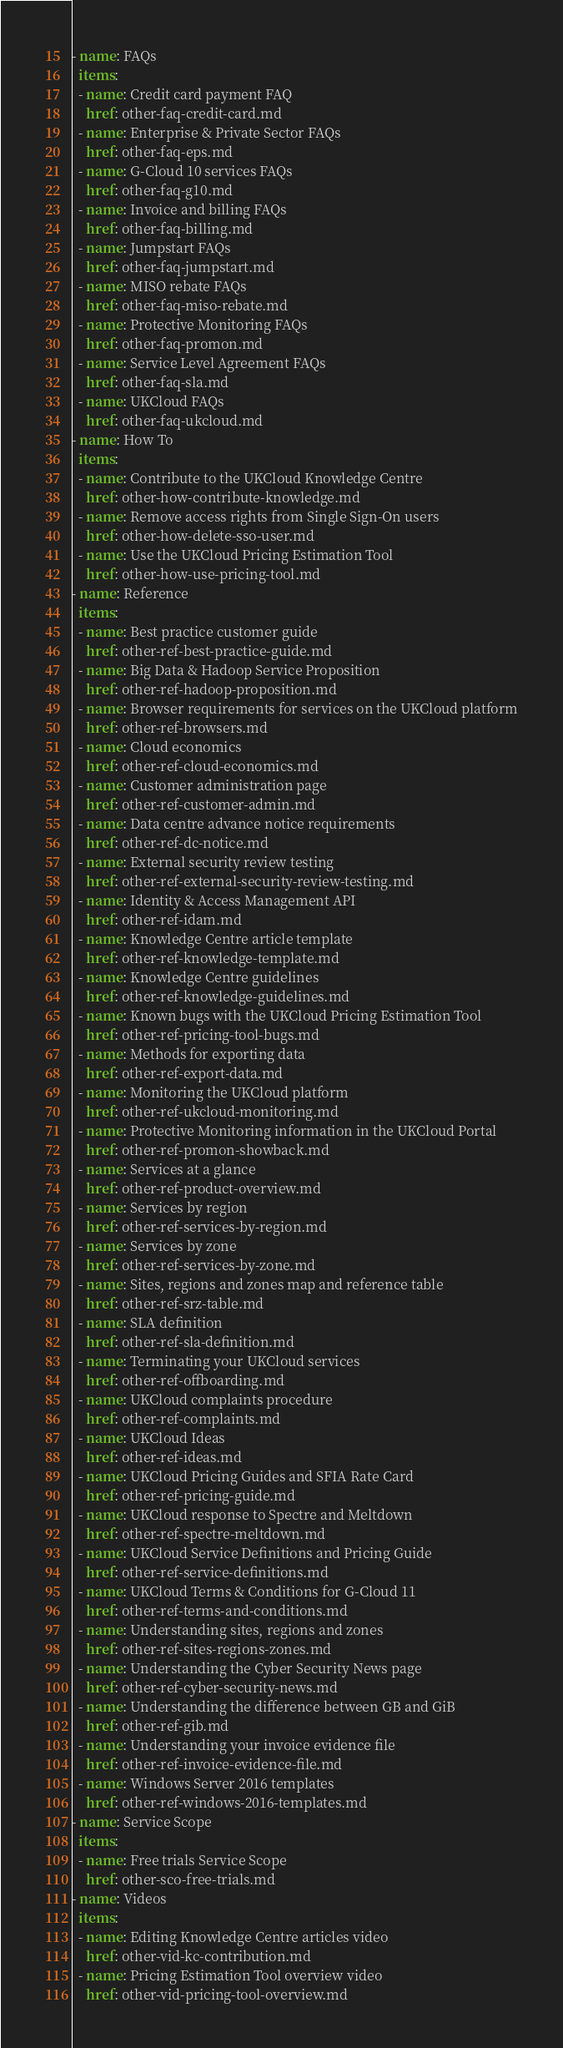<code> <loc_0><loc_0><loc_500><loc_500><_YAML_>- name: FAQs
  items:
  - name: Credit card payment FAQ
    href: other-faq-credit-card.md
  - name: Enterprise & Private Sector FAQs
    href: other-faq-eps.md
  - name: G-Cloud 10 services FAQs
    href: other-faq-g10.md
  - name: Invoice and billing FAQs
    href: other-faq-billing.md
  - name: Jumpstart FAQs
    href: other-faq-jumpstart.md
  - name: MISO rebate FAQs
    href: other-faq-miso-rebate.md
  - name: Protective Monitoring FAQs
    href: other-faq-promon.md
  - name: Service Level Agreement FAQs
    href: other-faq-sla.md
  - name: UKCloud FAQs
    href: other-faq-ukcloud.md
- name: How To
  items:
  - name: Contribute to the UKCloud Knowledge Centre
    href: other-how-contribute-knowledge.md
  - name: Remove access rights from Single Sign-On users
    href: other-how-delete-sso-user.md
  - name: Use the UKCloud Pricing Estimation Tool
    href: other-how-use-pricing-tool.md
- name: Reference
  items:
  - name: Best practice customer guide
    href: other-ref-best-practice-guide.md
  - name: Big Data & Hadoop Service Proposition
    href: other-ref-hadoop-proposition.md
  - name: Browser requirements for services on the UKCloud platform
    href: other-ref-browsers.md
  - name: Cloud economics
    href: other-ref-cloud-economics.md
  - name: Customer administration page
    href: other-ref-customer-admin.md
  - name: Data centre advance notice requirements
    href: other-ref-dc-notice.md
  - name: External security review testing
    href: other-ref-external-security-review-testing.md
  - name: Identity & Access Management API
    href: other-ref-idam.md
  - name: Knowledge Centre article template
    href: other-ref-knowledge-template.md
  - name: Knowledge Centre guidelines
    href: other-ref-knowledge-guidelines.md
  - name: Known bugs with the UKCloud Pricing Estimation Tool
    href: other-ref-pricing-tool-bugs.md
  - name: Methods for exporting data
    href: other-ref-export-data.md
  - name: Monitoring the UKCloud platform
    href: other-ref-ukcloud-monitoring.md
  - name: Protective Monitoring information in the UKCloud Portal
    href: other-ref-promon-showback.md
  - name: Services at a glance
    href: other-ref-product-overview.md
  - name: Services by region
    href: other-ref-services-by-region.md
  - name: Services by zone
    href: other-ref-services-by-zone.md
  - name: Sites, regions and zones map and reference table
    href: other-ref-srz-table.md
  - name: SLA definition
    href: other-ref-sla-definition.md
  - name: Terminating your UKCloud services
    href: other-ref-offboarding.md
  - name: UKCloud complaints procedure
    href: other-ref-complaints.md
  - name: UKCloud Ideas
    href: other-ref-ideas.md
  - name: UKCloud Pricing Guides and SFIA Rate Card
    href: other-ref-pricing-guide.md
  - name: UKCloud response to Spectre and Meltdown
    href: other-ref-spectre-meltdown.md
  - name: UKCloud Service Definitions and Pricing Guide
    href: other-ref-service-definitions.md
  - name: UKCloud Terms & Conditions for G-Cloud 11
    href: other-ref-terms-and-conditions.md
  - name: Understanding sites, regions and zones
    href: other-ref-sites-regions-zones.md
  - name: Understanding the Cyber Security News page
    href: other-ref-cyber-security-news.md
  - name: Understanding the difference between GB and GiB
    href: other-ref-gib.md
  - name: Understanding your invoice evidence file
    href: other-ref-invoice-evidence-file.md
  - name: Windows Server 2016 templates
    href: other-ref-windows-2016-templates.md
- name: Service Scope
  items:
  - name: Free trials Service Scope
    href: other-sco-free-trials.md
- name: Videos
  items:
  - name: Editing Knowledge Centre articles video
    href: other-vid-kc-contribution.md
  - name: Pricing Estimation Tool overview video
    href: other-vid-pricing-tool-overview.md
</code> 